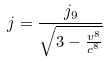<formula> <loc_0><loc_0><loc_500><loc_500>j = \frac { j _ { 9 } } { \sqrt { 3 - \frac { v ^ { 8 } } { c ^ { 8 } } } }</formula> 